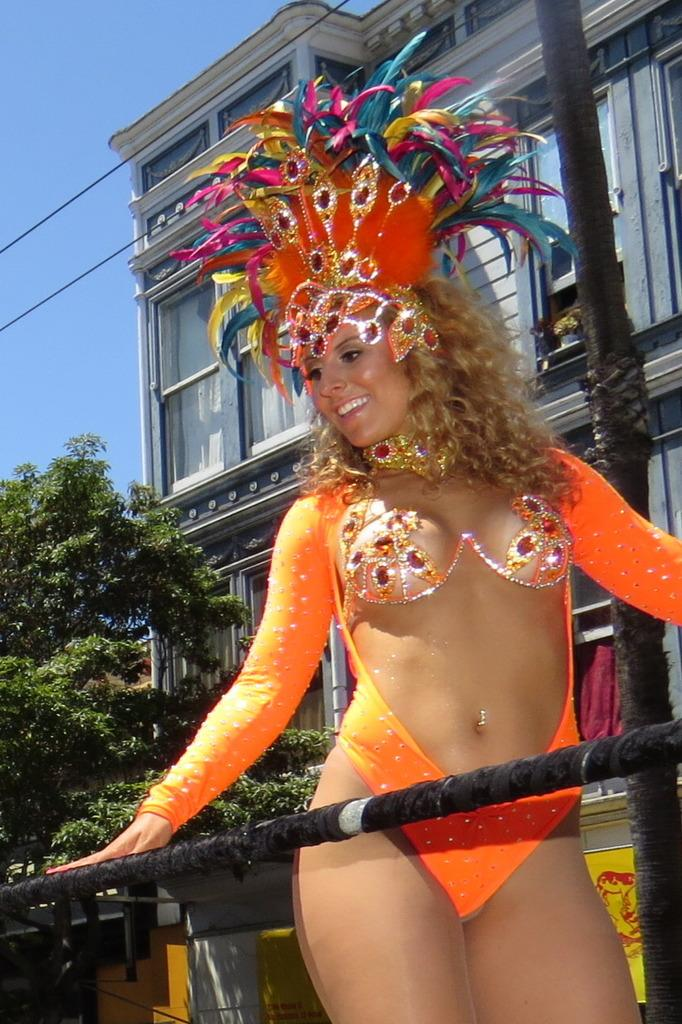What is the lady in the image wearing? The lady in the image is wearing a costume. What is located near the lady? There is a pole near the lady. What can be seen in the background of the image? There is a building, a tree, and the sky visible in the background of the image. What type of nut is the lady holding in the image? There is no nut present in the image; the lady is wearing a costume and standing near a pole. 